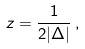<formula> <loc_0><loc_0><loc_500><loc_500>z = \frac { 1 } { 2 | \Delta | } \, ,</formula> 